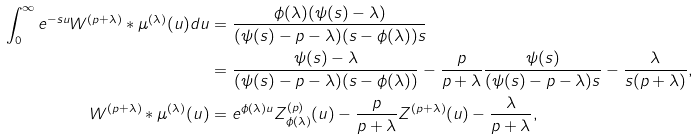Convert formula to latex. <formula><loc_0><loc_0><loc_500><loc_500>\int _ { 0 } ^ { \infty } e ^ { - s u } W ^ { ( p + \lambda ) } * \mu ^ { ( \lambda ) } ( u ) d u = & \ \frac { \phi ( \lambda ) ( \psi ( s ) - \lambda ) } { ( \psi ( s ) - p - \lambda ) ( s - \phi ( \lambda ) ) s } \\ = & \ \frac { \psi ( s ) - \lambda } { ( \psi ( s ) - p - \lambda ) ( s - \phi ( \lambda ) ) } - \frac { p } { p + \lambda } \frac { \psi ( s ) } { ( \psi ( s ) - p - \lambda ) s } - \frac { \lambda } { s ( p + \lambda ) } , \\ W ^ { ( p + \lambda ) } * \mu ^ { ( \lambda ) } ( u ) = & \ e ^ { \phi ( \lambda ) u } Z ^ { ( p ) } _ { \phi ( \lambda ) } ( u ) - \frac { p } { p + \lambda } Z ^ { ( p + \lambda ) } ( u ) - \frac { \lambda } { p + \lambda } ,</formula> 